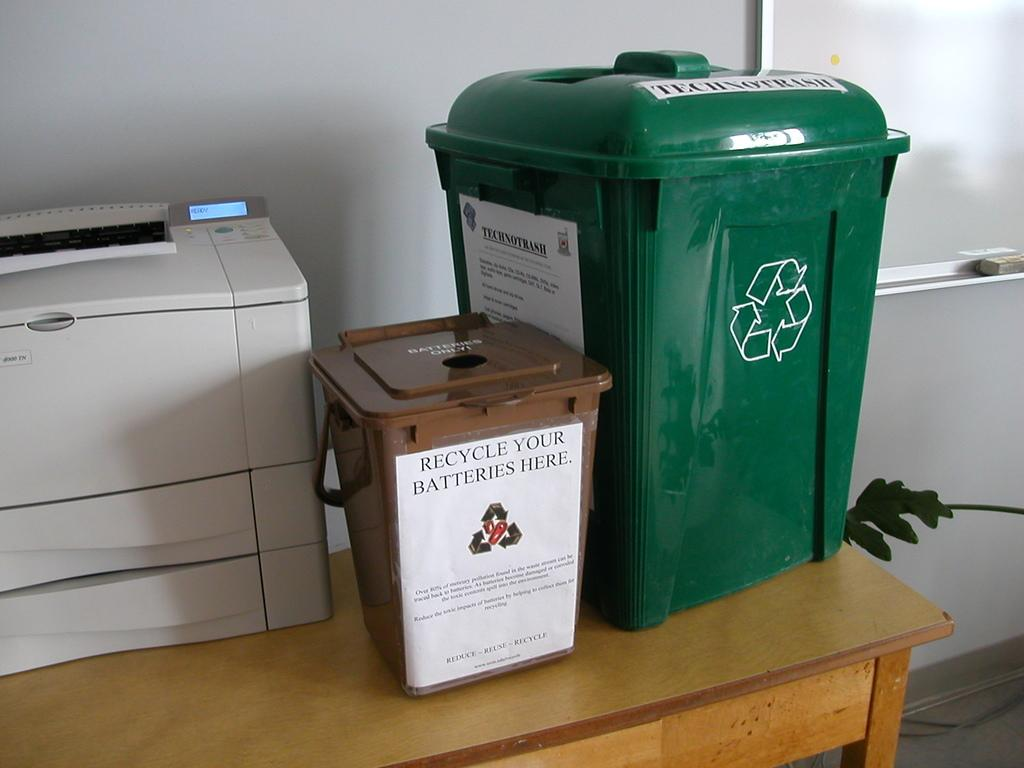<image>
Create a compact narrative representing the image presented. a recycle your batteries sign on a bin 